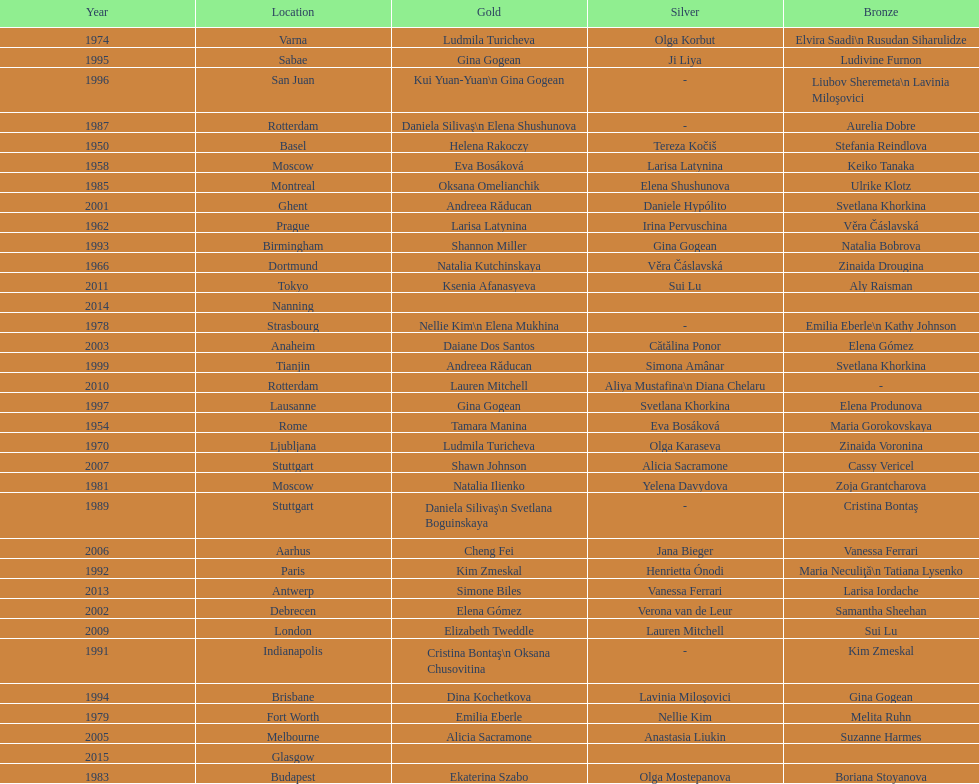Could you parse the entire table? {'header': ['Year', 'Location', 'Gold', 'Silver', 'Bronze'], 'rows': [['1974', 'Varna', 'Ludmila Turicheva', 'Olga Korbut', 'Elvira Saadi\\n Rusudan Siharulidze'], ['1995', 'Sabae', 'Gina Gogean', 'Ji Liya', 'Ludivine Furnon'], ['1996', 'San Juan', 'Kui Yuan-Yuan\\n Gina Gogean', '-', 'Liubov Sheremeta\\n Lavinia Miloşovici'], ['1987', 'Rotterdam', 'Daniela Silivaş\\n Elena Shushunova', '-', 'Aurelia Dobre'], ['1950', 'Basel', 'Helena Rakoczy', 'Tereza Kočiš', 'Stefania Reindlova'], ['1958', 'Moscow', 'Eva Bosáková', 'Larisa Latynina', 'Keiko Tanaka'], ['1985', 'Montreal', 'Oksana Omelianchik', 'Elena Shushunova', 'Ulrike Klotz'], ['2001', 'Ghent', 'Andreea Răducan', 'Daniele Hypólito', 'Svetlana Khorkina'], ['1962', 'Prague', 'Larisa Latynina', 'Irina Pervuschina', 'Věra Čáslavská'], ['1993', 'Birmingham', 'Shannon Miller', 'Gina Gogean', 'Natalia Bobrova'], ['1966', 'Dortmund', 'Natalia Kutchinskaya', 'Věra Čáslavská', 'Zinaida Drougina'], ['2011', 'Tokyo', 'Ksenia Afanasyeva', 'Sui Lu', 'Aly Raisman'], ['2014', 'Nanning', '', '', ''], ['1978', 'Strasbourg', 'Nellie Kim\\n Elena Mukhina', '-', 'Emilia Eberle\\n Kathy Johnson'], ['2003', 'Anaheim', 'Daiane Dos Santos', 'Cătălina Ponor', 'Elena Gómez'], ['1999', 'Tianjin', 'Andreea Răducan', 'Simona Amânar', 'Svetlana Khorkina'], ['2010', 'Rotterdam', 'Lauren Mitchell', 'Aliya Mustafina\\n Diana Chelaru', '-'], ['1997', 'Lausanne', 'Gina Gogean', 'Svetlana Khorkina', 'Elena Produnova'], ['1954', 'Rome', 'Tamara Manina', 'Eva Bosáková', 'Maria Gorokovskaya'], ['1970', 'Ljubljana', 'Ludmila Turicheva', 'Olga Karaseva', 'Zinaida Voronina'], ['2007', 'Stuttgart', 'Shawn Johnson', 'Alicia Sacramone', 'Cassy Vericel'], ['1981', 'Moscow', 'Natalia Ilienko', 'Yelena Davydova', 'Zoja Grantcharova'], ['1989', 'Stuttgart', 'Daniela Silivaş\\n Svetlana Boguinskaya', '-', 'Cristina Bontaş'], ['2006', 'Aarhus', 'Cheng Fei', 'Jana Bieger', 'Vanessa Ferrari'], ['1992', 'Paris', 'Kim Zmeskal', 'Henrietta Ónodi', 'Maria Neculiţă\\n Tatiana Lysenko'], ['2013', 'Antwerp', 'Simone Biles', 'Vanessa Ferrari', 'Larisa Iordache'], ['2002', 'Debrecen', 'Elena Gómez', 'Verona van de Leur', 'Samantha Sheehan'], ['2009', 'London', 'Elizabeth Tweddle', 'Lauren Mitchell', 'Sui Lu'], ['1991', 'Indianapolis', 'Cristina Bontaş\\n Oksana Chusovitina', '-', 'Kim Zmeskal'], ['1994', 'Brisbane', 'Dina Kochetkova', 'Lavinia Miloşovici', 'Gina Gogean'], ['1979', 'Fort Worth', 'Emilia Eberle', 'Nellie Kim', 'Melita Ruhn'], ['2005', 'Melbourne', 'Alicia Sacramone', 'Anastasia Liukin', 'Suzanne Harmes'], ['2015', 'Glasgow', '', '', ''], ['1983', 'Budapest', 'Ekaterina Szabo', 'Olga Mostepanova', 'Boriana Stoyanova']]} What is the number of times a brazilian has won a medal? 2. 